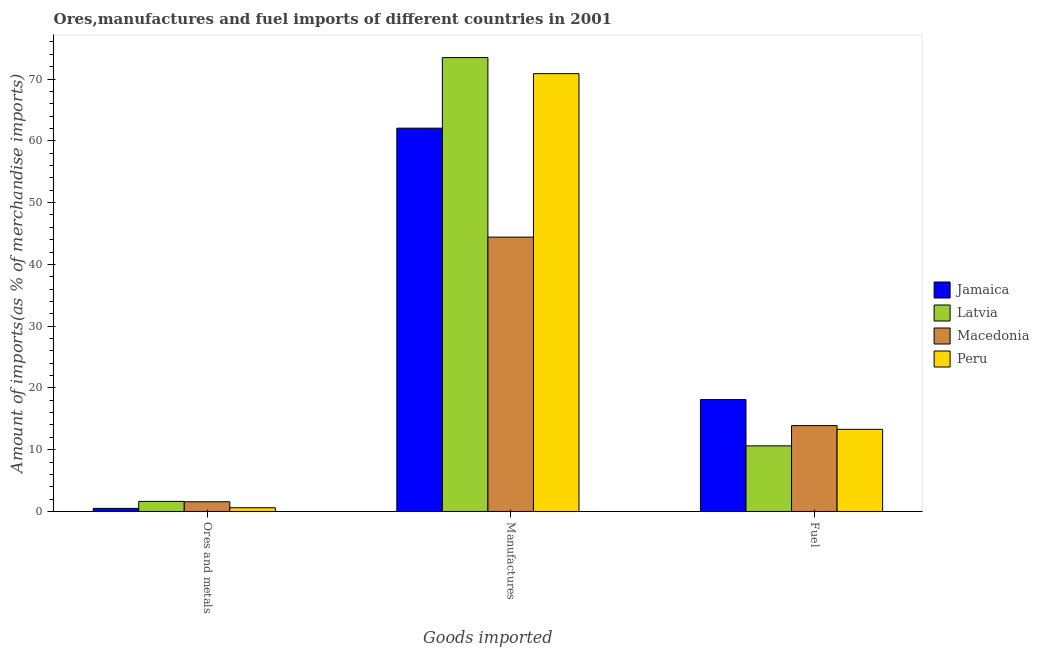How many different coloured bars are there?
Offer a terse response. 4. Are the number of bars per tick equal to the number of legend labels?
Provide a succinct answer. Yes. How many bars are there on the 1st tick from the left?
Keep it short and to the point. 4. What is the label of the 1st group of bars from the left?
Offer a very short reply. Ores and metals. What is the percentage of fuel imports in Jamaica?
Offer a very short reply. 18.11. Across all countries, what is the maximum percentage of fuel imports?
Your response must be concise. 18.11. Across all countries, what is the minimum percentage of fuel imports?
Keep it short and to the point. 10.62. In which country was the percentage of manufactures imports maximum?
Give a very brief answer. Latvia. In which country was the percentage of ores and metals imports minimum?
Ensure brevity in your answer.  Jamaica. What is the total percentage of fuel imports in the graph?
Provide a short and direct response. 55.94. What is the difference between the percentage of fuel imports in Macedonia and that in Latvia?
Give a very brief answer. 3.28. What is the difference between the percentage of fuel imports in Latvia and the percentage of ores and metals imports in Peru?
Keep it short and to the point. 10.02. What is the average percentage of ores and metals imports per country?
Your answer should be very brief. 1.08. What is the difference between the percentage of ores and metals imports and percentage of fuel imports in Peru?
Provide a short and direct response. -12.69. What is the ratio of the percentage of manufactures imports in Jamaica to that in Latvia?
Make the answer very short. 0.84. Is the difference between the percentage of ores and metals imports in Jamaica and Macedonia greater than the difference between the percentage of manufactures imports in Jamaica and Macedonia?
Your answer should be very brief. No. What is the difference between the highest and the second highest percentage of ores and metals imports?
Provide a short and direct response. 0.06. What is the difference between the highest and the lowest percentage of fuel imports?
Give a very brief answer. 7.49. In how many countries, is the percentage of ores and metals imports greater than the average percentage of ores and metals imports taken over all countries?
Provide a succinct answer. 2. Is the sum of the percentage of ores and metals imports in Peru and Macedonia greater than the maximum percentage of manufactures imports across all countries?
Your answer should be compact. No. How many legend labels are there?
Your answer should be very brief. 4. What is the title of the graph?
Make the answer very short. Ores,manufactures and fuel imports of different countries in 2001. What is the label or title of the X-axis?
Offer a very short reply. Goods imported. What is the label or title of the Y-axis?
Ensure brevity in your answer.  Amount of imports(as % of merchandise imports). What is the Amount of imports(as % of merchandise imports) of Jamaica in Ores and metals?
Your answer should be very brief. 0.5. What is the Amount of imports(as % of merchandise imports) in Latvia in Ores and metals?
Make the answer very short. 1.63. What is the Amount of imports(as % of merchandise imports) in Macedonia in Ores and metals?
Offer a very short reply. 1.57. What is the Amount of imports(as % of merchandise imports) in Peru in Ores and metals?
Keep it short and to the point. 0.61. What is the Amount of imports(as % of merchandise imports) in Jamaica in Manufactures?
Your answer should be compact. 62.05. What is the Amount of imports(as % of merchandise imports) in Latvia in Manufactures?
Your answer should be compact. 73.48. What is the Amount of imports(as % of merchandise imports) in Macedonia in Manufactures?
Make the answer very short. 44.41. What is the Amount of imports(as % of merchandise imports) in Peru in Manufactures?
Ensure brevity in your answer.  70.87. What is the Amount of imports(as % of merchandise imports) in Jamaica in Fuel?
Your response must be concise. 18.11. What is the Amount of imports(as % of merchandise imports) in Latvia in Fuel?
Provide a succinct answer. 10.62. What is the Amount of imports(as % of merchandise imports) in Macedonia in Fuel?
Your answer should be compact. 13.9. What is the Amount of imports(as % of merchandise imports) of Peru in Fuel?
Your answer should be very brief. 13.3. Across all Goods imported, what is the maximum Amount of imports(as % of merchandise imports) of Jamaica?
Keep it short and to the point. 62.05. Across all Goods imported, what is the maximum Amount of imports(as % of merchandise imports) in Latvia?
Ensure brevity in your answer.  73.48. Across all Goods imported, what is the maximum Amount of imports(as % of merchandise imports) in Macedonia?
Your answer should be compact. 44.41. Across all Goods imported, what is the maximum Amount of imports(as % of merchandise imports) of Peru?
Keep it short and to the point. 70.87. Across all Goods imported, what is the minimum Amount of imports(as % of merchandise imports) of Jamaica?
Give a very brief answer. 0.5. Across all Goods imported, what is the minimum Amount of imports(as % of merchandise imports) in Latvia?
Provide a succinct answer. 1.63. Across all Goods imported, what is the minimum Amount of imports(as % of merchandise imports) in Macedonia?
Your response must be concise. 1.57. Across all Goods imported, what is the minimum Amount of imports(as % of merchandise imports) in Peru?
Provide a short and direct response. 0.61. What is the total Amount of imports(as % of merchandise imports) of Jamaica in the graph?
Ensure brevity in your answer.  80.67. What is the total Amount of imports(as % of merchandise imports) in Latvia in the graph?
Provide a succinct answer. 85.73. What is the total Amount of imports(as % of merchandise imports) of Macedonia in the graph?
Your answer should be compact. 59.89. What is the total Amount of imports(as % of merchandise imports) of Peru in the graph?
Your answer should be very brief. 84.78. What is the difference between the Amount of imports(as % of merchandise imports) in Jamaica in Ores and metals and that in Manufactures?
Offer a very short reply. -61.55. What is the difference between the Amount of imports(as % of merchandise imports) in Latvia in Ores and metals and that in Manufactures?
Provide a succinct answer. -71.84. What is the difference between the Amount of imports(as % of merchandise imports) in Macedonia in Ores and metals and that in Manufactures?
Make the answer very short. -42.84. What is the difference between the Amount of imports(as % of merchandise imports) in Peru in Ores and metals and that in Manufactures?
Give a very brief answer. -70.27. What is the difference between the Amount of imports(as % of merchandise imports) in Jamaica in Ores and metals and that in Fuel?
Give a very brief answer. -17.61. What is the difference between the Amount of imports(as % of merchandise imports) in Latvia in Ores and metals and that in Fuel?
Your response must be concise. -8.99. What is the difference between the Amount of imports(as % of merchandise imports) of Macedonia in Ores and metals and that in Fuel?
Keep it short and to the point. -12.33. What is the difference between the Amount of imports(as % of merchandise imports) in Peru in Ores and metals and that in Fuel?
Keep it short and to the point. -12.69. What is the difference between the Amount of imports(as % of merchandise imports) of Jamaica in Manufactures and that in Fuel?
Your answer should be very brief. 43.93. What is the difference between the Amount of imports(as % of merchandise imports) in Latvia in Manufactures and that in Fuel?
Give a very brief answer. 62.85. What is the difference between the Amount of imports(as % of merchandise imports) of Macedonia in Manufactures and that in Fuel?
Your answer should be compact. 30.51. What is the difference between the Amount of imports(as % of merchandise imports) in Peru in Manufactures and that in Fuel?
Your response must be concise. 57.57. What is the difference between the Amount of imports(as % of merchandise imports) of Jamaica in Ores and metals and the Amount of imports(as % of merchandise imports) of Latvia in Manufactures?
Offer a very short reply. -72.97. What is the difference between the Amount of imports(as % of merchandise imports) in Jamaica in Ores and metals and the Amount of imports(as % of merchandise imports) in Macedonia in Manufactures?
Your response must be concise. -43.91. What is the difference between the Amount of imports(as % of merchandise imports) in Jamaica in Ores and metals and the Amount of imports(as % of merchandise imports) in Peru in Manufactures?
Offer a terse response. -70.37. What is the difference between the Amount of imports(as % of merchandise imports) of Latvia in Ores and metals and the Amount of imports(as % of merchandise imports) of Macedonia in Manufactures?
Your response must be concise. -42.78. What is the difference between the Amount of imports(as % of merchandise imports) of Latvia in Ores and metals and the Amount of imports(as % of merchandise imports) of Peru in Manufactures?
Provide a succinct answer. -69.24. What is the difference between the Amount of imports(as % of merchandise imports) of Macedonia in Ores and metals and the Amount of imports(as % of merchandise imports) of Peru in Manufactures?
Your answer should be compact. -69.3. What is the difference between the Amount of imports(as % of merchandise imports) of Jamaica in Ores and metals and the Amount of imports(as % of merchandise imports) of Latvia in Fuel?
Give a very brief answer. -10.12. What is the difference between the Amount of imports(as % of merchandise imports) of Jamaica in Ores and metals and the Amount of imports(as % of merchandise imports) of Macedonia in Fuel?
Give a very brief answer. -13.4. What is the difference between the Amount of imports(as % of merchandise imports) of Jamaica in Ores and metals and the Amount of imports(as % of merchandise imports) of Peru in Fuel?
Give a very brief answer. -12.8. What is the difference between the Amount of imports(as % of merchandise imports) in Latvia in Ores and metals and the Amount of imports(as % of merchandise imports) in Macedonia in Fuel?
Offer a very short reply. -12.27. What is the difference between the Amount of imports(as % of merchandise imports) of Latvia in Ores and metals and the Amount of imports(as % of merchandise imports) of Peru in Fuel?
Your answer should be very brief. -11.67. What is the difference between the Amount of imports(as % of merchandise imports) in Macedonia in Ores and metals and the Amount of imports(as % of merchandise imports) in Peru in Fuel?
Your answer should be compact. -11.73. What is the difference between the Amount of imports(as % of merchandise imports) in Jamaica in Manufactures and the Amount of imports(as % of merchandise imports) in Latvia in Fuel?
Provide a succinct answer. 51.43. What is the difference between the Amount of imports(as % of merchandise imports) in Jamaica in Manufactures and the Amount of imports(as % of merchandise imports) in Macedonia in Fuel?
Ensure brevity in your answer.  48.15. What is the difference between the Amount of imports(as % of merchandise imports) of Jamaica in Manufactures and the Amount of imports(as % of merchandise imports) of Peru in Fuel?
Your answer should be compact. 48.75. What is the difference between the Amount of imports(as % of merchandise imports) of Latvia in Manufactures and the Amount of imports(as % of merchandise imports) of Macedonia in Fuel?
Your answer should be compact. 59.58. What is the difference between the Amount of imports(as % of merchandise imports) in Latvia in Manufactures and the Amount of imports(as % of merchandise imports) in Peru in Fuel?
Your answer should be compact. 60.18. What is the difference between the Amount of imports(as % of merchandise imports) in Macedonia in Manufactures and the Amount of imports(as % of merchandise imports) in Peru in Fuel?
Your response must be concise. 31.11. What is the average Amount of imports(as % of merchandise imports) in Jamaica per Goods imported?
Give a very brief answer. 26.89. What is the average Amount of imports(as % of merchandise imports) in Latvia per Goods imported?
Ensure brevity in your answer.  28.58. What is the average Amount of imports(as % of merchandise imports) of Macedonia per Goods imported?
Ensure brevity in your answer.  19.96. What is the average Amount of imports(as % of merchandise imports) of Peru per Goods imported?
Your answer should be compact. 28.26. What is the difference between the Amount of imports(as % of merchandise imports) of Jamaica and Amount of imports(as % of merchandise imports) of Latvia in Ores and metals?
Give a very brief answer. -1.13. What is the difference between the Amount of imports(as % of merchandise imports) in Jamaica and Amount of imports(as % of merchandise imports) in Macedonia in Ores and metals?
Your answer should be very brief. -1.07. What is the difference between the Amount of imports(as % of merchandise imports) of Jamaica and Amount of imports(as % of merchandise imports) of Peru in Ores and metals?
Give a very brief answer. -0.1. What is the difference between the Amount of imports(as % of merchandise imports) of Latvia and Amount of imports(as % of merchandise imports) of Macedonia in Ores and metals?
Give a very brief answer. 0.06. What is the difference between the Amount of imports(as % of merchandise imports) of Latvia and Amount of imports(as % of merchandise imports) of Peru in Ores and metals?
Ensure brevity in your answer.  1.03. What is the difference between the Amount of imports(as % of merchandise imports) of Jamaica and Amount of imports(as % of merchandise imports) of Latvia in Manufactures?
Provide a short and direct response. -11.43. What is the difference between the Amount of imports(as % of merchandise imports) of Jamaica and Amount of imports(as % of merchandise imports) of Macedonia in Manufactures?
Provide a short and direct response. 17.64. What is the difference between the Amount of imports(as % of merchandise imports) in Jamaica and Amount of imports(as % of merchandise imports) in Peru in Manufactures?
Your answer should be very brief. -8.82. What is the difference between the Amount of imports(as % of merchandise imports) of Latvia and Amount of imports(as % of merchandise imports) of Macedonia in Manufactures?
Offer a very short reply. 29.06. What is the difference between the Amount of imports(as % of merchandise imports) in Latvia and Amount of imports(as % of merchandise imports) in Peru in Manufactures?
Ensure brevity in your answer.  2.6. What is the difference between the Amount of imports(as % of merchandise imports) in Macedonia and Amount of imports(as % of merchandise imports) in Peru in Manufactures?
Keep it short and to the point. -26.46. What is the difference between the Amount of imports(as % of merchandise imports) in Jamaica and Amount of imports(as % of merchandise imports) in Latvia in Fuel?
Give a very brief answer. 7.49. What is the difference between the Amount of imports(as % of merchandise imports) in Jamaica and Amount of imports(as % of merchandise imports) in Macedonia in Fuel?
Keep it short and to the point. 4.21. What is the difference between the Amount of imports(as % of merchandise imports) of Jamaica and Amount of imports(as % of merchandise imports) of Peru in Fuel?
Give a very brief answer. 4.82. What is the difference between the Amount of imports(as % of merchandise imports) in Latvia and Amount of imports(as % of merchandise imports) in Macedonia in Fuel?
Your answer should be very brief. -3.28. What is the difference between the Amount of imports(as % of merchandise imports) in Latvia and Amount of imports(as % of merchandise imports) in Peru in Fuel?
Offer a very short reply. -2.68. What is the difference between the Amount of imports(as % of merchandise imports) in Macedonia and Amount of imports(as % of merchandise imports) in Peru in Fuel?
Offer a very short reply. 0.6. What is the ratio of the Amount of imports(as % of merchandise imports) in Jamaica in Ores and metals to that in Manufactures?
Your response must be concise. 0.01. What is the ratio of the Amount of imports(as % of merchandise imports) in Latvia in Ores and metals to that in Manufactures?
Keep it short and to the point. 0.02. What is the ratio of the Amount of imports(as % of merchandise imports) of Macedonia in Ores and metals to that in Manufactures?
Your response must be concise. 0.04. What is the ratio of the Amount of imports(as % of merchandise imports) of Peru in Ores and metals to that in Manufactures?
Offer a very short reply. 0.01. What is the ratio of the Amount of imports(as % of merchandise imports) in Jamaica in Ores and metals to that in Fuel?
Provide a succinct answer. 0.03. What is the ratio of the Amount of imports(as % of merchandise imports) of Latvia in Ores and metals to that in Fuel?
Your answer should be compact. 0.15. What is the ratio of the Amount of imports(as % of merchandise imports) in Macedonia in Ores and metals to that in Fuel?
Make the answer very short. 0.11. What is the ratio of the Amount of imports(as % of merchandise imports) of Peru in Ores and metals to that in Fuel?
Ensure brevity in your answer.  0.05. What is the ratio of the Amount of imports(as % of merchandise imports) of Jamaica in Manufactures to that in Fuel?
Provide a succinct answer. 3.43. What is the ratio of the Amount of imports(as % of merchandise imports) of Latvia in Manufactures to that in Fuel?
Your response must be concise. 6.92. What is the ratio of the Amount of imports(as % of merchandise imports) in Macedonia in Manufactures to that in Fuel?
Your answer should be compact. 3.19. What is the ratio of the Amount of imports(as % of merchandise imports) of Peru in Manufactures to that in Fuel?
Ensure brevity in your answer.  5.33. What is the difference between the highest and the second highest Amount of imports(as % of merchandise imports) in Jamaica?
Offer a terse response. 43.93. What is the difference between the highest and the second highest Amount of imports(as % of merchandise imports) in Latvia?
Your answer should be very brief. 62.85. What is the difference between the highest and the second highest Amount of imports(as % of merchandise imports) of Macedonia?
Offer a terse response. 30.51. What is the difference between the highest and the second highest Amount of imports(as % of merchandise imports) in Peru?
Make the answer very short. 57.57. What is the difference between the highest and the lowest Amount of imports(as % of merchandise imports) in Jamaica?
Keep it short and to the point. 61.55. What is the difference between the highest and the lowest Amount of imports(as % of merchandise imports) in Latvia?
Keep it short and to the point. 71.84. What is the difference between the highest and the lowest Amount of imports(as % of merchandise imports) in Macedonia?
Make the answer very short. 42.84. What is the difference between the highest and the lowest Amount of imports(as % of merchandise imports) of Peru?
Your answer should be compact. 70.27. 